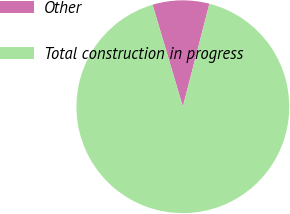Convert chart. <chart><loc_0><loc_0><loc_500><loc_500><pie_chart><fcel>Other<fcel>Total construction in progress<nl><fcel>8.61%<fcel>91.39%<nl></chart> 